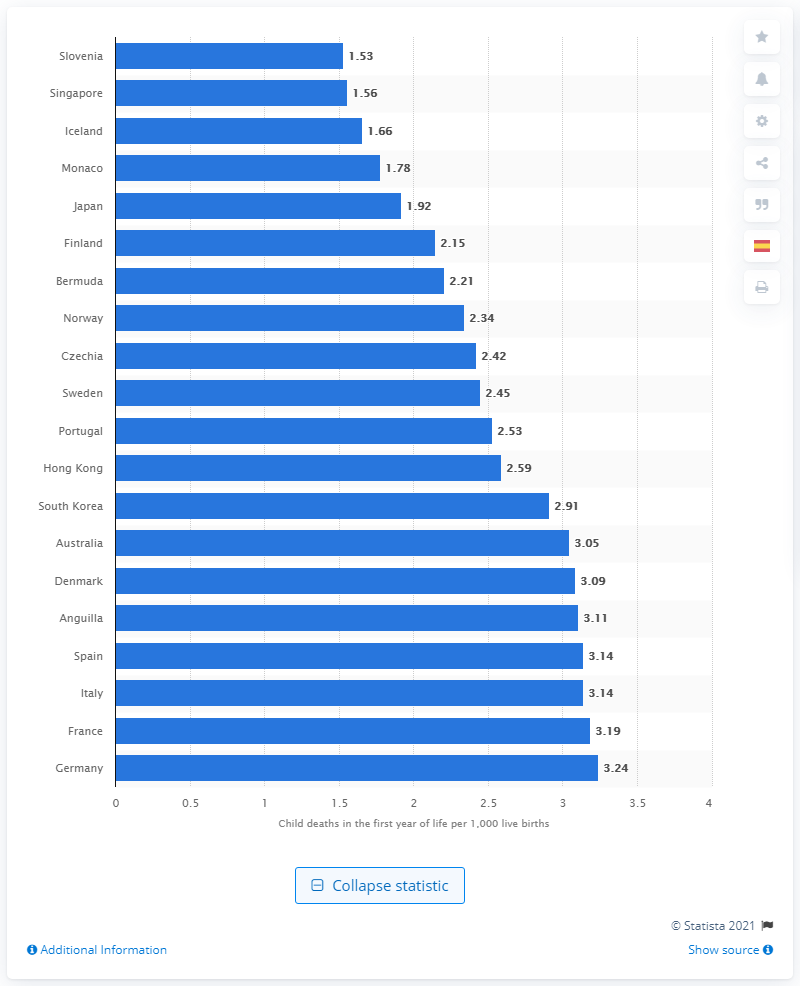Specify some key components in this picture. In the first year of life in 2021, there were 1.53 live births that died in Slovenia. 